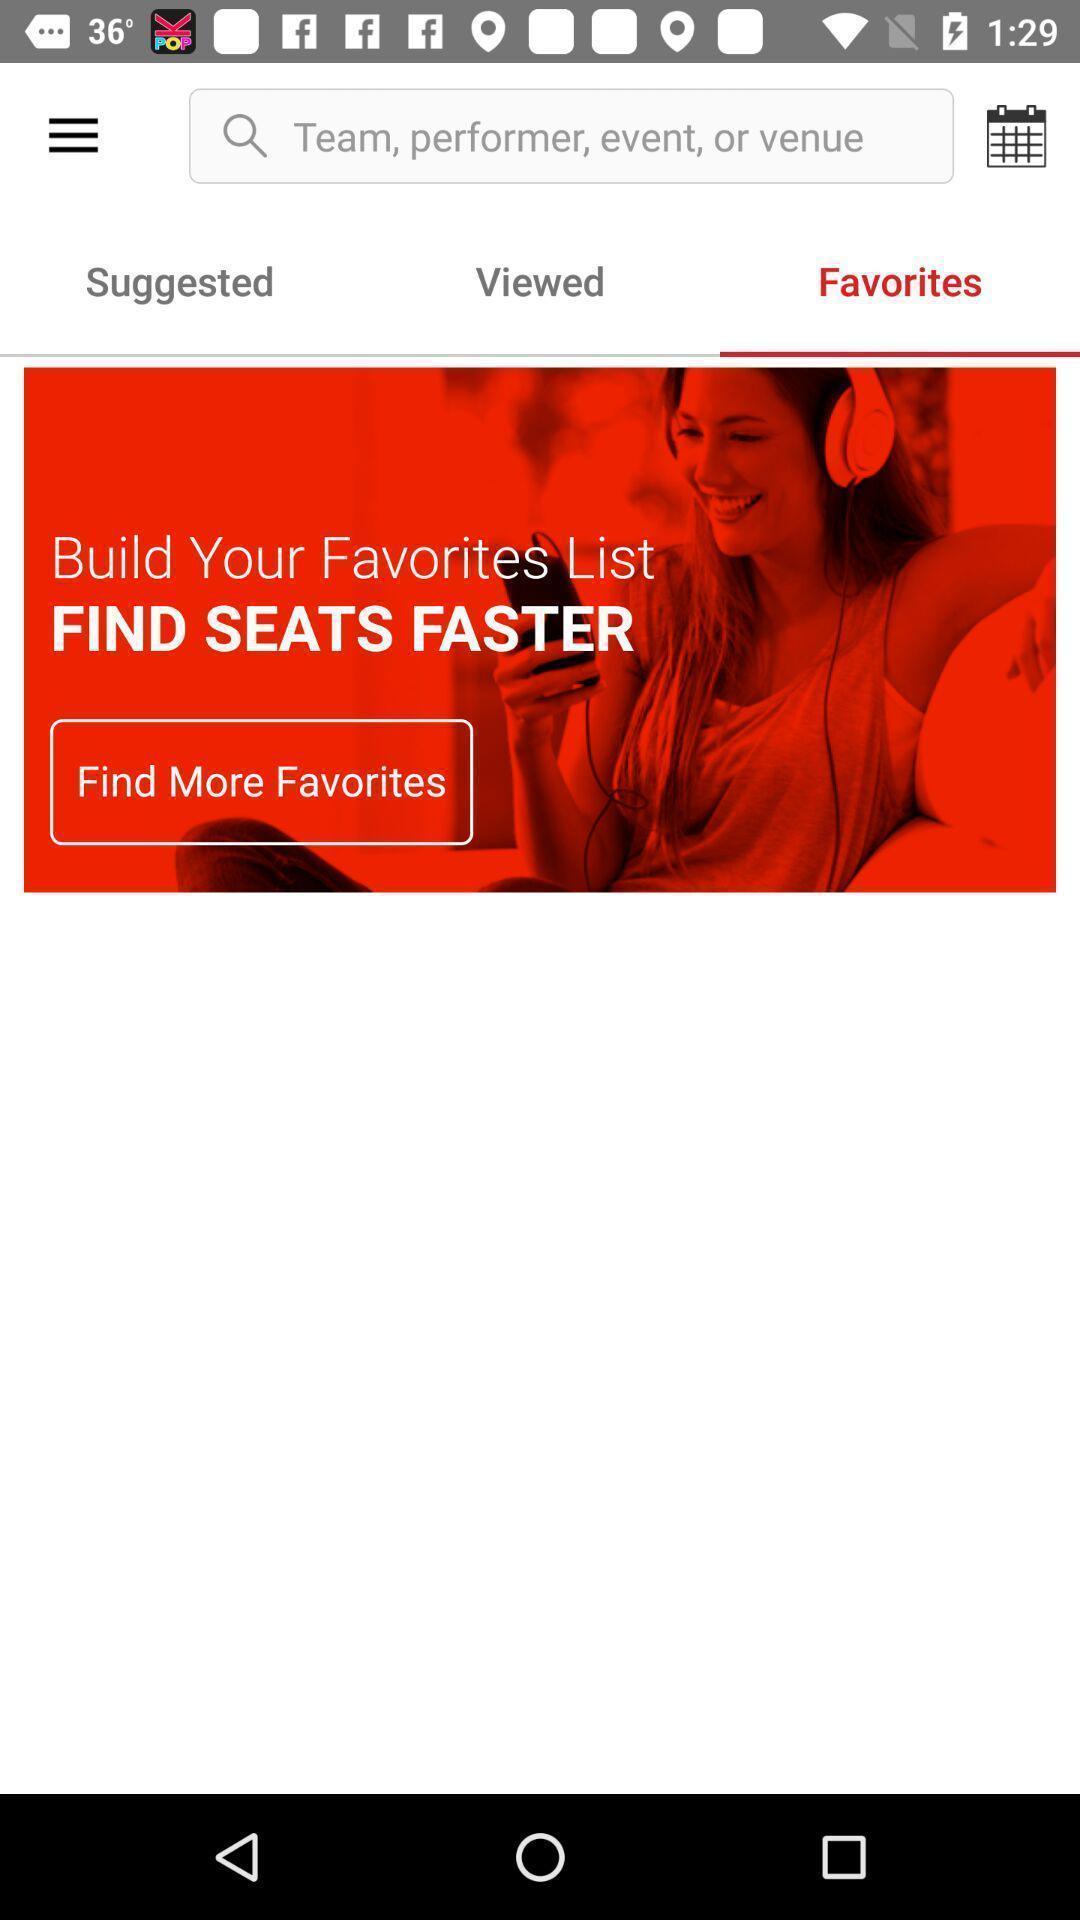Describe the visual elements of this screenshot. Screen showing favorites page. 